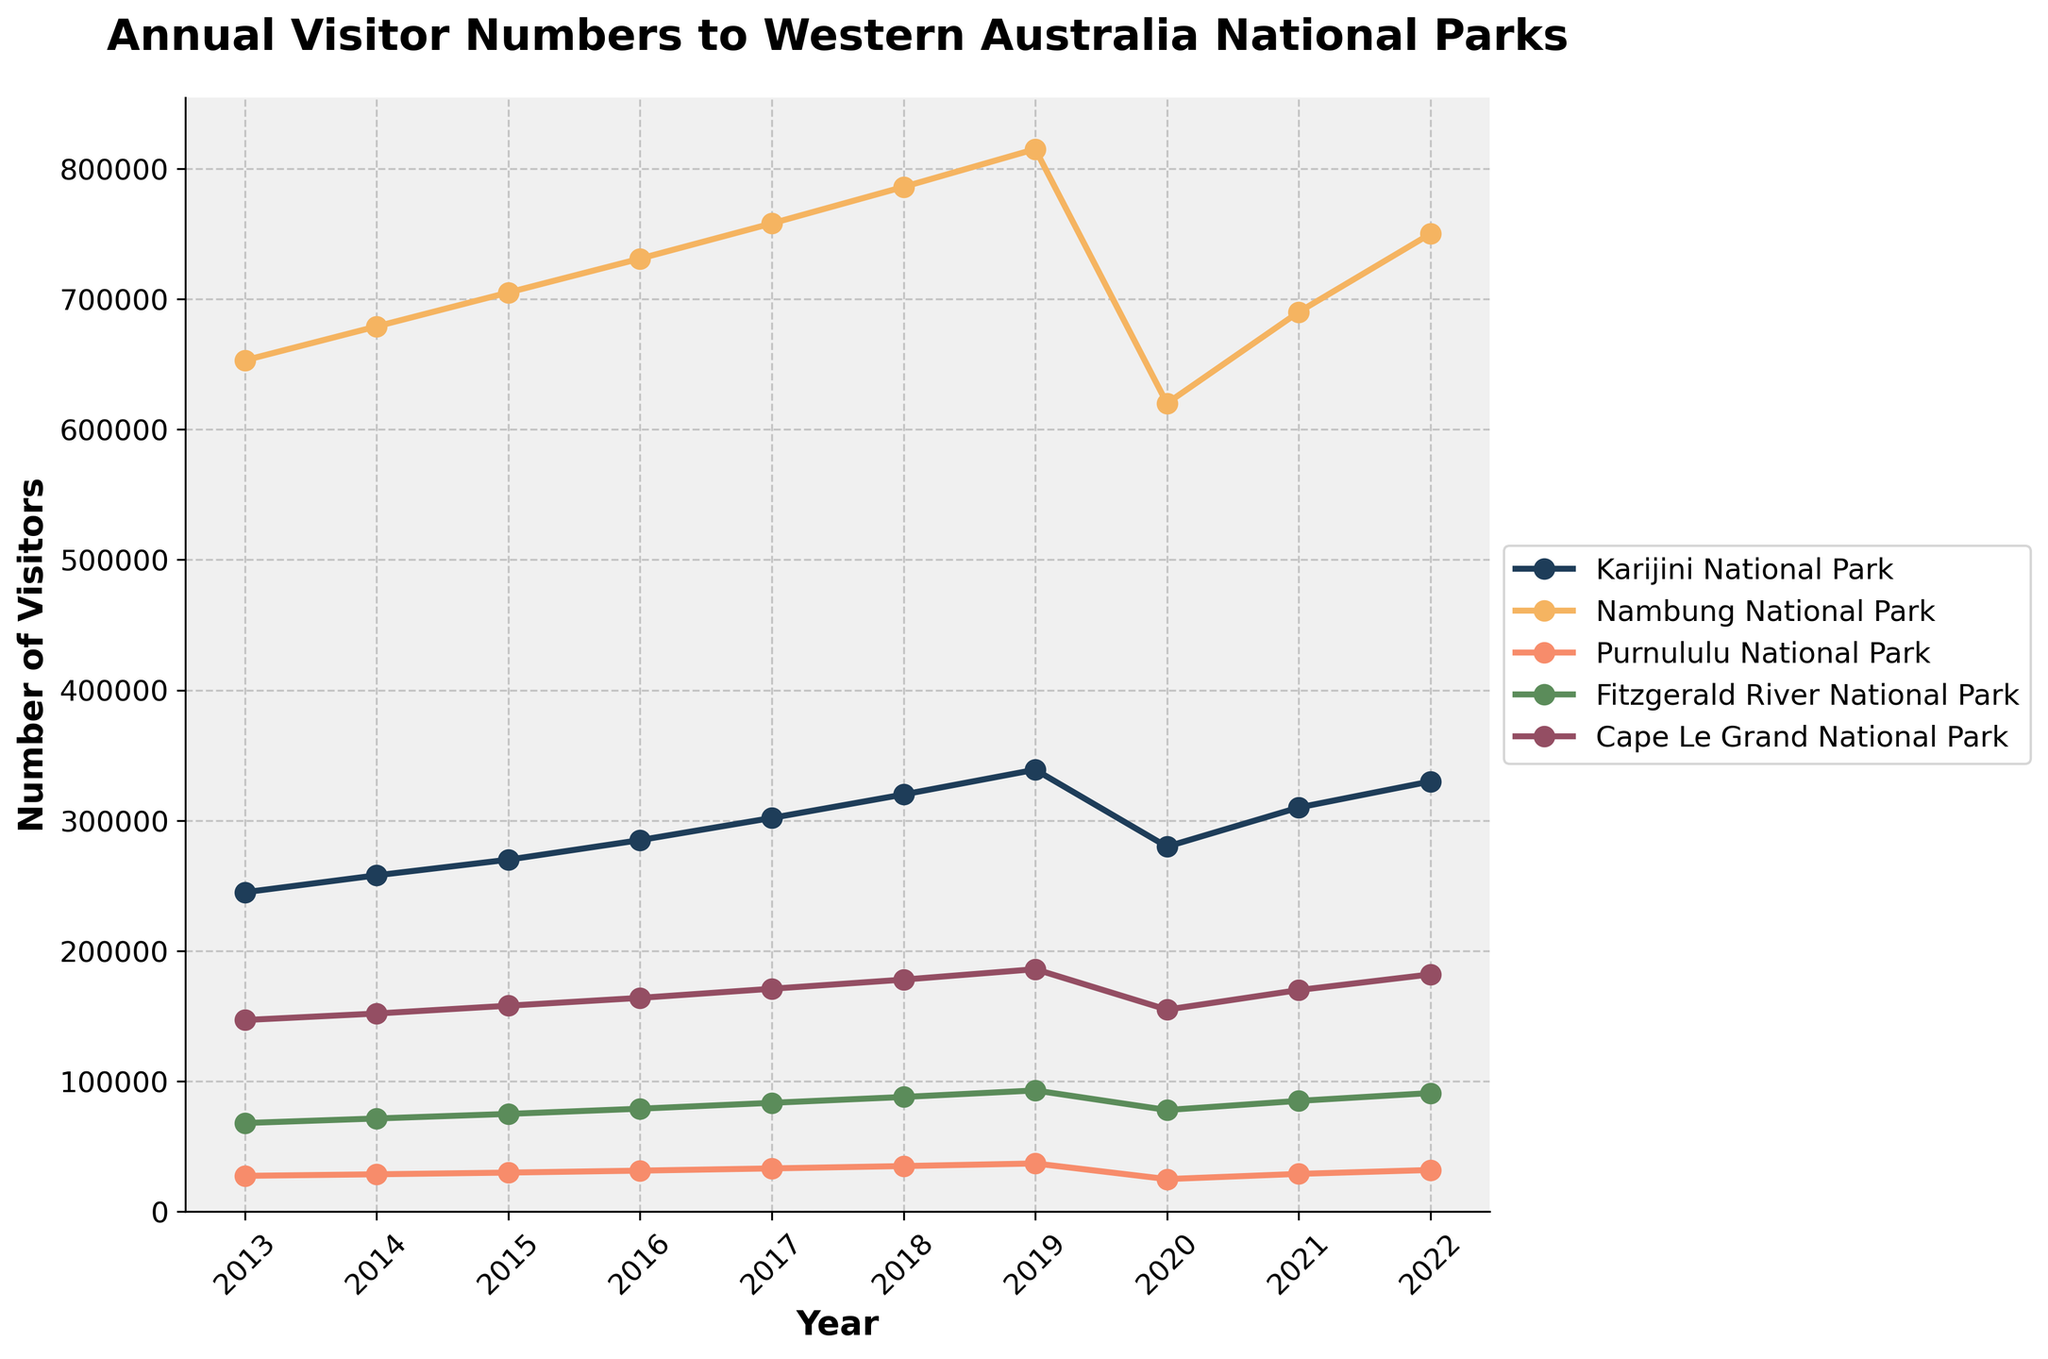What are the visitor numbers for Karijini and Purnululu National Parks in 2020? First, identify the year 2020 on the x-axis, then locate the corresponding lines for Karijini and Purnululu. From the y-axis values, Karijini National Park had 280,000 visitors and Purnululu National Park had 25,000 visitors.
Answer: Karijini: 280,000; Purnululu: 25,000 Which national park had the highest number of visitors in 2022? Look at the year 2022 on the x-axis and compare the heights of all the lines representing different parks. The line representing Nambung National Park is the highest.
Answer: Nambung National Park How did the visitor numbers to Cape Le Grand National Park change from 2019 to 2020? Check the y-values for Cape Le Grand National Park for the years 2019 and 2020. It had 186,000 visitors in 2019 and 155,000 in 2020. The change is 186,000 - 155,000 = 31,000 fewer visitors in 2020.
Answer: Decreased by 31,000 Which two years do we see a significant drop in visitor numbers for nearly all parks? Observe the trends and identify dips in all lines representing different parks. The drop is most noticeable from 2019 to 2020.
Answer: 2019 to 2020 What is the average number of visitors for Fitzgerald River National Park between 2015 and 2017? Find the visitor numbers for Fitzgerald River National Park in 2015, 2016, and 2017: 75,000, 79,000, and 83,500 respectively. Calculate the average: (75,000 + 79,000 + 83,500) / 3 = 79,833.33.
Answer: 79,833 Which park had a steady increase in visitors over the decade before a sudden drop and recovery? Look for a line showing a steady rise followed by a notable drop and subsequent recovery. Karijini National Park shows this pattern with steady increases until 2019, a drop in 2020, and recovery in 2021 and 2022.
Answer: Karijini National Park Between which years did Purnululu National Park see the highest rate of increase? Observe the slope of the line for Purnululu National Park and identify the steepest upward slope. The steepest slope occurs between 2018 and 2019.
Answer: 2018 to 2019 How many more visitors did Nambung National Park have compared to Fitzgerald River National Park in 2021? For 2021, Nambung National Park had 690,000 visitors and Fitzgerald River National Park had 85,000. The difference is 690,000 - 85,000 = 605,000.
Answer: 605,000 Which park showed the least variability in annual visitor numbers throughout the decade? Compare the fluctuations in the lines. Purnululu National Park shows the least variability, having lower and more consistent visitor numbers.
Answer: Purnululu National Park 